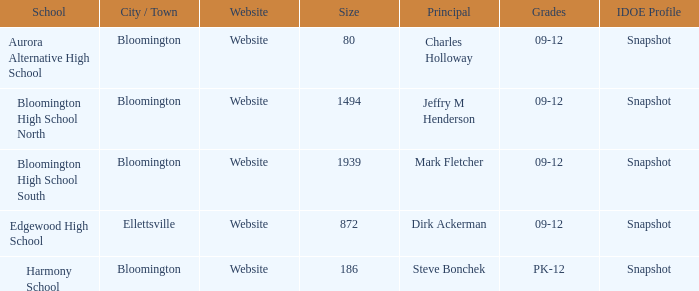How many websites are there for the school with 1939 students? 1.0. 